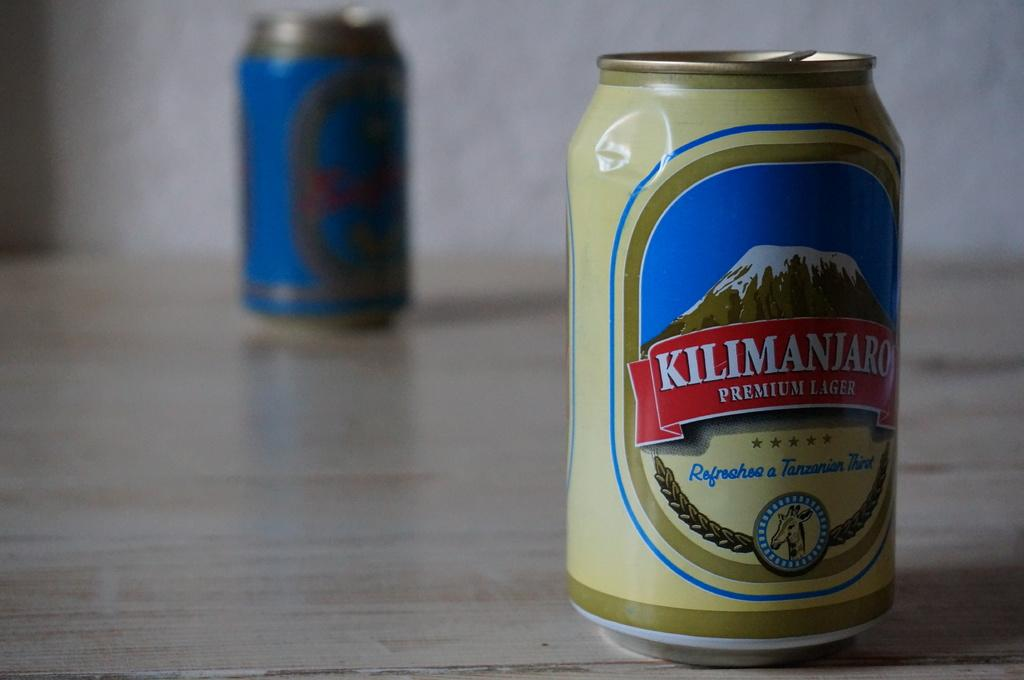<image>
Summarize the visual content of the image. The can of Kilimanjaro lager has a little dent in it, toward the top. 